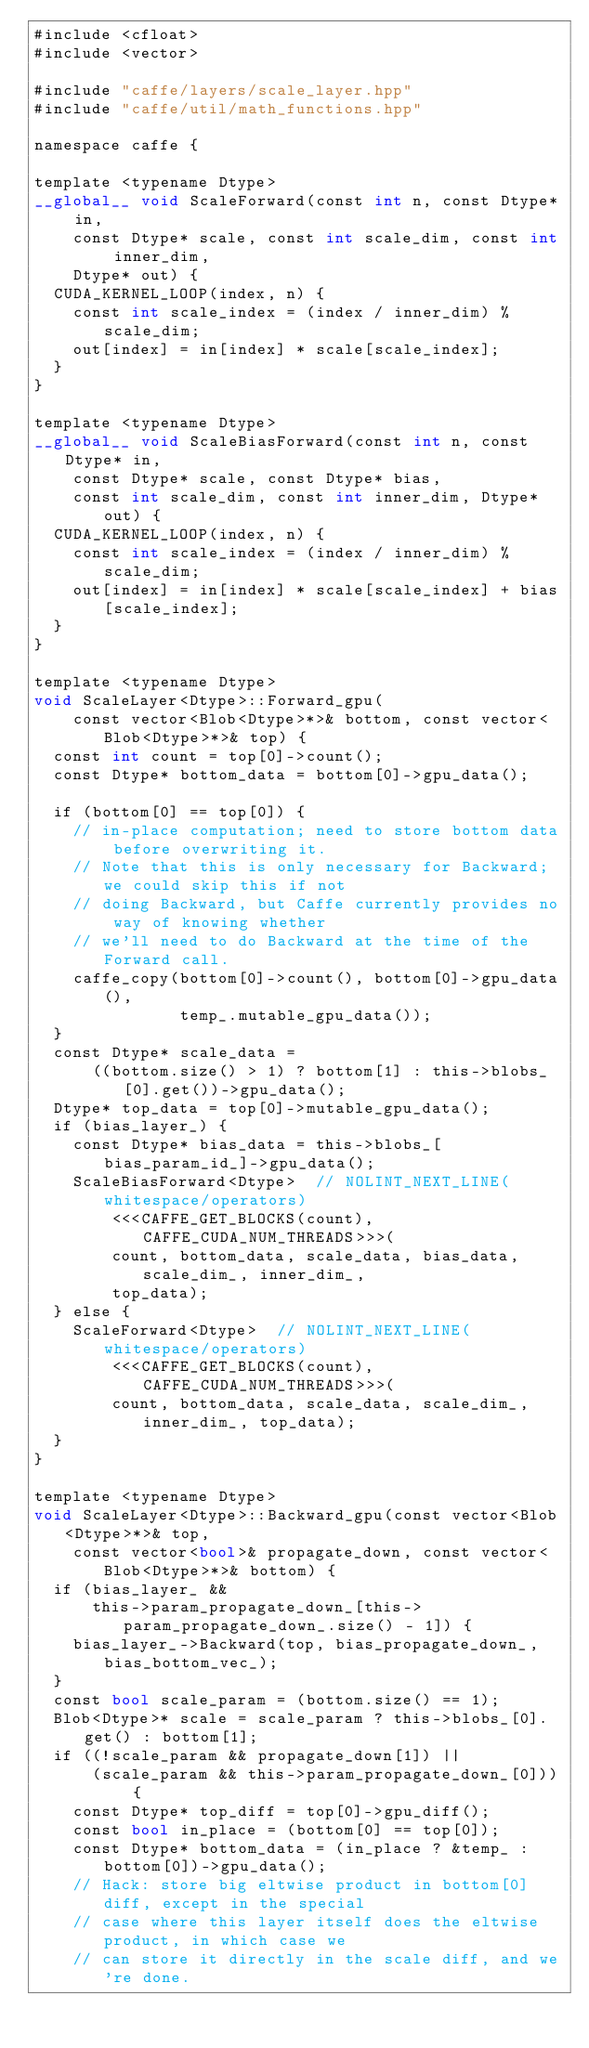Convert code to text. <code><loc_0><loc_0><loc_500><loc_500><_Cuda_>#include <cfloat>
#include <vector>

#include "caffe/layers/scale_layer.hpp"
#include "caffe/util/math_functions.hpp"

namespace caffe {

template <typename Dtype>
__global__ void ScaleForward(const int n, const Dtype* in,
    const Dtype* scale, const int scale_dim, const int inner_dim,
    Dtype* out) {
  CUDA_KERNEL_LOOP(index, n) {
    const int scale_index = (index / inner_dim) % scale_dim;
    out[index] = in[index] * scale[scale_index];
  }
}

template <typename Dtype>
__global__ void ScaleBiasForward(const int n, const Dtype* in,
    const Dtype* scale, const Dtype* bias,
    const int scale_dim, const int inner_dim, Dtype* out) {
  CUDA_KERNEL_LOOP(index, n) {
    const int scale_index = (index / inner_dim) % scale_dim;
    out[index] = in[index] * scale[scale_index] + bias[scale_index];
  }
}

template <typename Dtype>
void ScaleLayer<Dtype>::Forward_gpu(
    const vector<Blob<Dtype>*>& bottom, const vector<Blob<Dtype>*>& top) {
  const int count = top[0]->count();
  const Dtype* bottom_data = bottom[0]->gpu_data();
 
  if (bottom[0] == top[0]) {
    // in-place computation; need to store bottom data before overwriting it.
    // Note that this is only necessary for Backward; we could skip this if not
    // doing Backward, but Caffe currently provides no way of knowing whether
    // we'll need to do Backward at the time of the Forward call.
    caffe_copy(bottom[0]->count(), bottom[0]->gpu_data(),
               temp_.mutable_gpu_data());
  }
  const Dtype* scale_data =
      ((bottom.size() > 1) ? bottom[1] : this->blobs_[0].get())->gpu_data();
  Dtype* top_data = top[0]->mutable_gpu_data();
  if (bias_layer_) {
    const Dtype* bias_data = this->blobs_[bias_param_id_]->gpu_data();
    ScaleBiasForward<Dtype>  // NOLINT_NEXT_LINE(whitespace/operators)
        <<<CAFFE_GET_BLOCKS(count), CAFFE_CUDA_NUM_THREADS>>>(
        count, bottom_data, scale_data, bias_data, scale_dim_, inner_dim_,
        top_data);
  } else {
    ScaleForward<Dtype>  // NOLINT_NEXT_LINE(whitespace/operators)
        <<<CAFFE_GET_BLOCKS(count), CAFFE_CUDA_NUM_THREADS>>>(
        count, bottom_data, scale_data, scale_dim_, inner_dim_, top_data);
  }
}

template <typename Dtype>
void ScaleLayer<Dtype>::Backward_gpu(const vector<Blob<Dtype>*>& top,
    const vector<bool>& propagate_down, const vector<Blob<Dtype>*>& bottom) {
  if (bias_layer_ &&
      this->param_propagate_down_[this->param_propagate_down_.size() - 1]) {
    bias_layer_->Backward(top, bias_propagate_down_, bias_bottom_vec_);
  }
  const bool scale_param = (bottom.size() == 1);
  Blob<Dtype>* scale = scale_param ? this->blobs_[0].get() : bottom[1];
  if ((!scale_param && propagate_down[1]) ||
      (scale_param && this->param_propagate_down_[0])) {
    const Dtype* top_diff = top[0]->gpu_diff();
    const bool in_place = (bottom[0] == top[0]);
    const Dtype* bottom_data = (in_place ? &temp_ : bottom[0])->gpu_data();
    // Hack: store big eltwise product in bottom[0] diff, except in the special
    // case where this layer itself does the eltwise product, in which case we
    // can store it directly in the scale diff, and we're done.</code> 